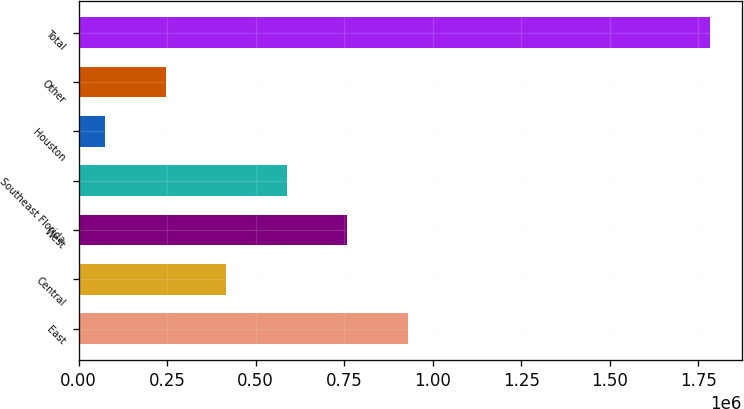Convert chart to OTSL. <chart><loc_0><loc_0><loc_500><loc_500><bar_chart><fcel>East<fcel>Central<fcel>West<fcel>Southeast Florida<fcel>Houston<fcel>Other<fcel>Total<nl><fcel>929200<fcel>417211<fcel>758537<fcel>587874<fcel>75884<fcel>246547<fcel>1.78252e+06<nl></chart> 